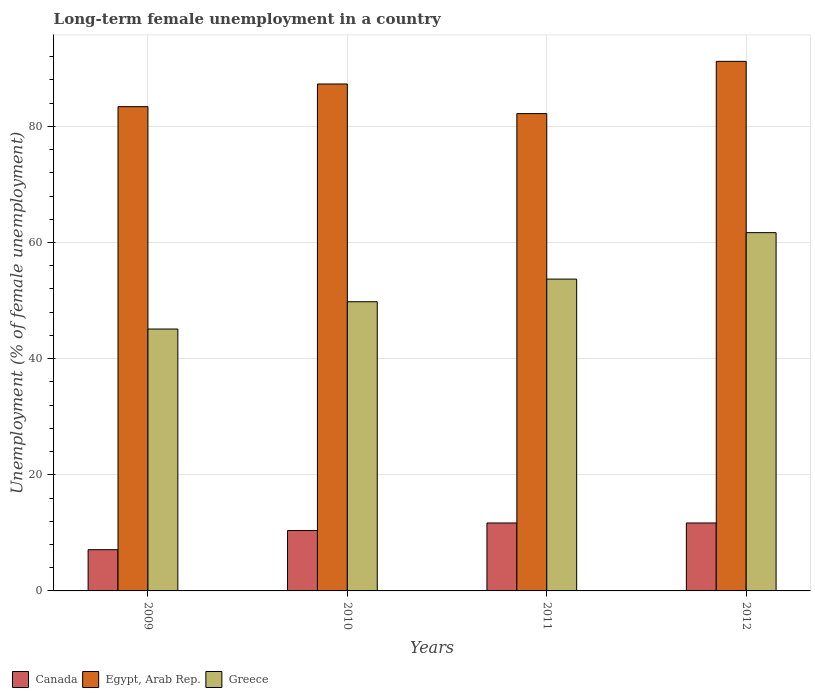How many different coloured bars are there?
Offer a terse response. 3. Are the number of bars on each tick of the X-axis equal?
Ensure brevity in your answer.  Yes. How many bars are there on the 4th tick from the left?
Your answer should be very brief. 3. What is the label of the 4th group of bars from the left?
Make the answer very short. 2012. What is the percentage of long-term unemployed female population in Egypt, Arab Rep. in 2010?
Offer a terse response. 87.3. Across all years, what is the maximum percentage of long-term unemployed female population in Greece?
Give a very brief answer. 61.7. Across all years, what is the minimum percentage of long-term unemployed female population in Egypt, Arab Rep.?
Your answer should be very brief. 82.2. In which year was the percentage of long-term unemployed female population in Canada minimum?
Your answer should be compact. 2009. What is the total percentage of long-term unemployed female population in Greece in the graph?
Offer a terse response. 210.3. What is the difference between the percentage of long-term unemployed female population in Greece in 2009 and that in 2010?
Your answer should be compact. -4.7. What is the difference between the percentage of long-term unemployed female population in Greece in 2011 and the percentage of long-term unemployed female population in Egypt, Arab Rep. in 2009?
Make the answer very short. -29.7. What is the average percentage of long-term unemployed female population in Canada per year?
Your answer should be compact. 10.22. In the year 2012, what is the difference between the percentage of long-term unemployed female population in Greece and percentage of long-term unemployed female population in Canada?
Your response must be concise. 50. In how many years, is the percentage of long-term unemployed female population in Canada greater than 28 %?
Offer a terse response. 0. What is the ratio of the percentage of long-term unemployed female population in Egypt, Arab Rep. in 2009 to that in 2012?
Offer a very short reply. 0.91. Is the difference between the percentage of long-term unemployed female population in Greece in 2010 and 2012 greater than the difference between the percentage of long-term unemployed female population in Canada in 2010 and 2012?
Your answer should be very brief. No. What is the difference between the highest and the lowest percentage of long-term unemployed female population in Egypt, Arab Rep.?
Provide a short and direct response. 9. Is the sum of the percentage of long-term unemployed female population in Egypt, Arab Rep. in 2009 and 2010 greater than the maximum percentage of long-term unemployed female population in Canada across all years?
Keep it short and to the point. Yes. What does the 2nd bar from the left in 2012 represents?
Give a very brief answer. Egypt, Arab Rep. What does the 2nd bar from the right in 2011 represents?
Offer a very short reply. Egypt, Arab Rep. Is it the case that in every year, the sum of the percentage of long-term unemployed female population in Greece and percentage of long-term unemployed female population in Egypt, Arab Rep. is greater than the percentage of long-term unemployed female population in Canada?
Make the answer very short. Yes. How many years are there in the graph?
Your answer should be compact. 4. Are the values on the major ticks of Y-axis written in scientific E-notation?
Offer a very short reply. No. Does the graph contain grids?
Offer a terse response. Yes. What is the title of the graph?
Offer a very short reply. Long-term female unemployment in a country. Does "South Sudan" appear as one of the legend labels in the graph?
Provide a short and direct response. No. What is the label or title of the X-axis?
Provide a short and direct response. Years. What is the label or title of the Y-axis?
Your answer should be very brief. Unemployment (% of female unemployment). What is the Unemployment (% of female unemployment) in Canada in 2009?
Offer a very short reply. 7.1. What is the Unemployment (% of female unemployment) of Egypt, Arab Rep. in 2009?
Your response must be concise. 83.4. What is the Unemployment (% of female unemployment) in Greece in 2009?
Make the answer very short. 45.1. What is the Unemployment (% of female unemployment) of Canada in 2010?
Your response must be concise. 10.4. What is the Unemployment (% of female unemployment) of Egypt, Arab Rep. in 2010?
Keep it short and to the point. 87.3. What is the Unemployment (% of female unemployment) in Greece in 2010?
Your answer should be compact. 49.8. What is the Unemployment (% of female unemployment) in Canada in 2011?
Make the answer very short. 11.7. What is the Unemployment (% of female unemployment) of Egypt, Arab Rep. in 2011?
Keep it short and to the point. 82.2. What is the Unemployment (% of female unemployment) of Greece in 2011?
Your answer should be compact. 53.7. What is the Unemployment (% of female unemployment) of Canada in 2012?
Your response must be concise. 11.7. What is the Unemployment (% of female unemployment) in Egypt, Arab Rep. in 2012?
Offer a very short reply. 91.2. What is the Unemployment (% of female unemployment) of Greece in 2012?
Give a very brief answer. 61.7. Across all years, what is the maximum Unemployment (% of female unemployment) of Canada?
Make the answer very short. 11.7. Across all years, what is the maximum Unemployment (% of female unemployment) of Egypt, Arab Rep.?
Give a very brief answer. 91.2. Across all years, what is the maximum Unemployment (% of female unemployment) of Greece?
Keep it short and to the point. 61.7. Across all years, what is the minimum Unemployment (% of female unemployment) of Canada?
Make the answer very short. 7.1. Across all years, what is the minimum Unemployment (% of female unemployment) in Egypt, Arab Rep.?
Give a very brief answer. 82.2. Across all years, what is the minimum Unemployment (% of female unemployment) in Greece?
Provide a short and direct response. 45.1. What is the total Unemployment (% of female unemployment) in Canada in the graph?
Ensure brevity in your answer.  40.9. What is the total Unemployment (% of female unemployment) in Egypt, Arab Rep. in the graph?
Offer a very short reply. 344.1. What is the total Unemployment (% of female unemployment) in Greece in the graph?
Offer a terse response. 210.3. What is the difference between the Unemployment (% of female unemployment) in Canada in 2009 and that in 2011?
Your answer should be compact. -4.6. What is the difference between the Unemployment (% of female unemployment) of Greece in 2009 and that in 2011?
Your answer should be compact. -8.6. What is the difference between the Unemployment (% of female unemployment) of Canada in 2009 and that in 2012?
Make the answer very short. -4.6. What is the difference between the Unemployment (% of female unemployment) of Greece in 2009 and that in 2012?
Offer a terse response. -16.6. What is the difference between the Unemployment (% of female unemployment) in Canada in 2010 and that in 2011?
Your response must be concise. -1.3. What is the difference between the Unemployment (% of female unemployment) of Egypt, Arab Rep. in 2010 and that in 2011?
Offer a terse response. 5.1. What is the difference between the Unemployment (% of female unemployment) of Canada in 2010 and that in 2012?
Offer a very short reply. -1.3. What is the difference between the Unemployment (% of female unemployment) of Canada in 2011 and that in 2012?
Keep it short and to the point. 0. What is the difference between the Unemployment (% of female unemployment) of Egypt, Arab Rep. in 2011 and that in 2012?
Your answer should be compact. -9. What is the difference between the Unemployment (% of female unemployment) of Canada in 2009 and the Unemployment (% of female unemployment) of Egypt, Arab Rep. in 2010?
Provide a succinct answer. -80.2. What is the difference between the Unemployment (% of female unemployment) of Canada in 2009 and the Unemployment (% of female unemployment) of Greece in 2010?
Offer a terse response. -42.7. What is the difference between the Unemployment (% of female unemployment) of Egypt, Arab Rep. in 2009 and the Unemployment (% of female unemployment) of Greece in 2010?
Your response must be concise. 33.6. What is the difference between the Unemployment (% of female unemployment) of Canada in 2009 and the Unemployment (% of female unemployment) of Egypt, Arab Rep. in 2011?
Give a very brief answer. -75.1. What is the difference between the Unemployment (% of female unemployment) in Canada in 2009 and the Unemployment (% of female unemployment) in Greece in 2011?
Your response must be concise. -46.6. What is the difference between the Unemployment (% of female unemployment) of Egypt, Arab Rep. in 2009 and the Unemployment (% of female unemployment) of Greece in 2011?
Provide a succinct answer. 29.7. What is the difference between the Unemployment (% of female unemployment) of Canada in 2009 and the Unemployment (% of female unemployment) of Egypt, Arab Rep. in 2012?
Give a very brief answer. -84.1. What is the difference between the Unemployment (% of female unemployment) in Canada in 2009 and the Unemployment (% of female unemployment) in Greece in 2012?
Offer a very short reply. -54.6. What is the difference between the Unemployment (% of female unemployment) in Egypt, Arab Rep. in 2009 and the Unemployment (% of female unemployment) in Greece in 2012?
Keep it short and to the point. 21.7. What is the difference between the Unemployment (% of female unemployment) in Canada in 2010 and the Unemployment (% of female unemployment) in Egypt, Arab Rep. in 2011?
Your response must be concise. -71.8. What is the difference between the Unemployment (% of female unemployment) of Canada in 2010 and the Unemployment (% of female unemployment) of Greece in 2011?
Give a very brief answer. -43.3. What is the difference between the Unemployment (% of female unemployment) in Egypt, Arab Rep. in 2010 and the Unemployment (% of female unemployment) in Greece in 2011?
Your answer should be compact. 33.6. What is the difference between the Unemployment (% of female unemployment) in Canada in 2010 and the Unemployment (% of female unemployment) in Egypt, Arab Rep. in 2012?
Ensure brevity in your answer.  -80.8. What is the difference between the Unemployment (% of female unemployment) of Canada in 2010 and the Unemployment (% of female unemployment) of Greece in 2012?
Make the answer very short. -51.3. What is the difference between the Unemployment (% of female unemployment) of Egypt, Arab Rep. in 2010 and the Unemployment (% of female unemployment) of Greece in 2012?
Offer a terse response. 25.6. What is the difference between the Unemployment (% of female unemployment) in Canada in 2011 and the Unemployment (% of female unemployment) in Egypt, Arab Rep. in 2012?
Provide a succinct answer. -79.5. What is the difference between the Unemployment (% of female unemployment) of Egypt, Arab Rep. in 2011 and the Unemployment (% of female unemployment) of Greece in 2012?
Offer a terse response. 20.5. What is the average Unemployment (% of female unemployment) in Canada per year?
Offer a terse response. 10.22. What is the average Unemployment (% of female unemployment) of Egypt, Arab Rep. per year?
Provide a succinct answer. 86.03. What is the average Unemployment (% of female unemployment) in Greece per year?
Your response must be concise. 52.58. In the year 2009, what is the difference between the Unemployment (% of female unemployment) of Canada and Unemployment (% of female unemployment) of Egypt, Arab Rep.?
Keep it short and to the point. -76.3. In the year 2009, what is the difference between the Unemployment (% of female unemployment) of Canada and Unemployment (% of female unemployment) of Greece?
Your answer should be compact. -38. In the year 2009, what is the difference between the Unemployment (% of female unemployment) in Egypt, Arab Rep. and Unemployment (% of female unemployment) in Greece?
Your response must be concise. 38.3. In the year 2010, what is the difference between the Unemployment (% of female unemployment) of Canada and Unemployment (% of female unemployment) of Egypt, Arab Rep.?
Your answer should be compact. -76.9. In the year 2010, what is the difference between the Unemployment (% of female unemployment) in Canada and Unemployment (% of female unemployment) in Greece?
Offer a terse response. -39.4. In the year 2010, what is the difference between the Unemployment (% of female unemployment) in Egypt, Arab Rep. and Unemployment (% of female unemployment) in Greece?
Make the answer very short. 37.5. In the year 2011, what is the difference between the Unemployment (% of female unemployment) in Canada and Unemployment (% of female unemployment) in Egypt, Arab Rep.?
Offer a very short reply. -70.5. In the year 2011, what is the difference between the Unemployment (% of female unemployment) of Canada and Unemployment (% of female unemployment) of Greece?
Your response must be concise. -42. In the year 2012, what is the difference between the Unemployment (% of female unemployment) of Canada and Unemployment (% of female unemployment) of Egypt, Arab Rep.?
Offer a very short reply. -79.5. In the year 2012, what is the difference between the Unemployment (% of female unemployment) of Canada and Unemployment (% of female unemployment) of Greece?
Your answer should be compact. -50. In the year 2012, what is the difference between the Unemployment (% of female unemployment) in Egypt, Arab Rep. and Unemployment (% of female unemployment) in Greece?
Your response must be concise. 29.5. What is the ratio of the Unemployment (% of female unemployment) in Canada in 2009 to that in 2010?
Your response must be concise. 0.68. What is the ratio of the Unemployment (% of female unemployment) in Egypt, Arab Rep. in 2009 to that in 2010?
Offer a very short reply. 0.96. What is the ratio of the Unemployment (% of female unemployment) of Greece in 2009 to that in 2010?
Your answer should be very brief. 0.91. What is the ratio of the Unemployment (% of female unemployment) in Canada in 2009 to that in 2011?
Your response must be concise. 0.61. What is the ratio of the Unemployment (% of female unemployment) in Egypt, Arab Rep. in 2009 to that in 2011?
Offer a very short reply. 1.01. What is the ratio of the Unemployment (% of female unemployment) of Greece in 2009 to that in 2011?
Offer a terse response. 0.84. What is the ratio of the Unemployment (% of female unemployment) in Canada in 2009 to that in 2012?
Your response must be concise. 0.61. What is the ratio of the Unemployment (% of female unemployment) in Egypt, Arab Rep. in 2009 to that in 2012?
Offer a very short reply. 0.91. What is the ratio of the Unemployment (% of female unemployment) in Greece in 2009 to that in 2012?
Your answer should be very brief. 0.73. What is the ratio of the Unemployment (% of female unemployment) in Canada in 2010 to that in 2011?
Keep it short and to the point. 0.89. What is the ratio of the Unemployment (% of female unemployment) of Egypt, Arab Rep. in 2010 to that in 2011?
Ensure brevity in your answer.  1.06. What is the ratio of the Unemployment (% of female unemployment) in Greece in 2010 to that in 2011?
Your response must be concise. 0.93. What is the ratio of the Unemployment (% of female unemployment) of Egypt, Arab Rep. in 2010 to that in 2012?
Your answer should be compact. 0.96. What is the ratio of the Unemployment (% of female unemployment) of Greece in 2010 to that in 2012?
Offer a terse response. 0.81. What is the ratio of the Unemployment (% of female unemployment) in Canada in 2011 to that in 2012?
Your answer should be compact. 1. What is the ratio of the Unemployment (% of female unemployment) in Egypt, Arab Rep. in 2011 to that in 2012?
Your response must be concise. 0.9. What is the ratio of the Unemployment (% of female unemployment) of Greece in 2011 to that in 2012?
Make the answer very short. 0.87. What is the difference between the highest and the second highest Unemployment (% of female unemployment) of Egypt, Arab Rep.?
Offer a very short reply. 3.9. What is the difference between the highest and the second highest Unemployment (% of female unemployment) of Greece?
Provide a short and direct response. 8. What is the difference between the highest and the lowest Unemployment (% of female unemployment) of Greece?
Provide a short and direct response. 16.6. 